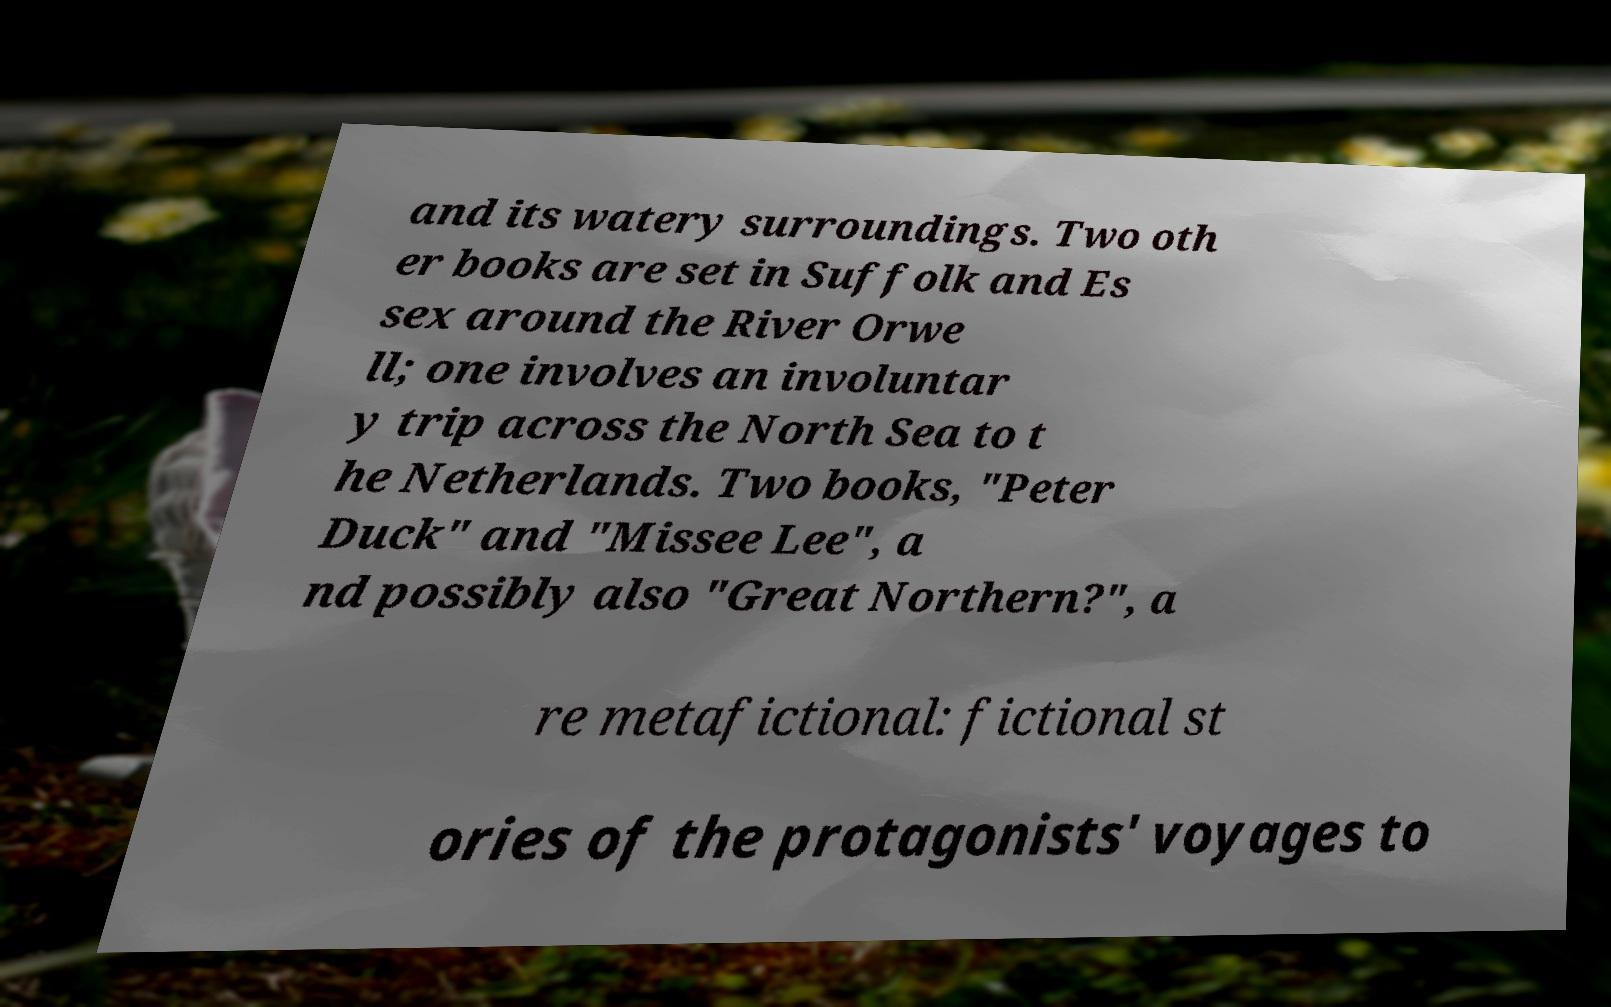Please identify and transcribe the text found in this image. and its watery surroundings. Two oth er books are set in Suffolk and Es sex around the River Orwe ll; one involves an involuntar y trip across the North Sea to t he Netherlands. Two books, "Peter Duck" and "Missee Lee", a nd possibly also "Great Northern?", a re metafictional: fictional st ories of the protagonists' voyages to 